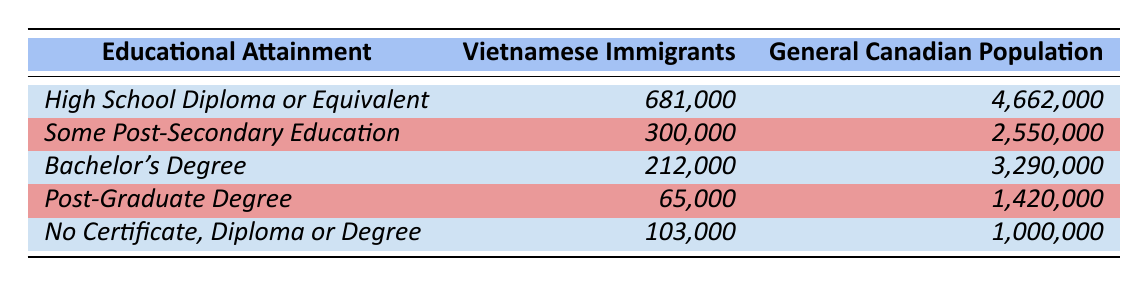What is the highest educational attainment level for Vietnamese immigrants? The table shows that the highest educational attainment level for Vietnamese immigrants is a "High School Diploma or Equivalent," which has the highest number at 681,000.
Answer: High School Diploma or Equivalent How many Vietnamese immigrants have a Bachelor's degree? According to the table, the number of Vietnamese immigrants with a Bachelor's degree is 212,000, as indicated in the corresponding row.
Answer: 212,000 What percentage of the general Canadian population has a Post-Graduate Degree? The total number of individuals in the general Canadian population is 4,662,000 + 2,550,000 + 3,290,000 + 1,420,000 + 1,000,000 = 12,922,000. The number of individuals with a Post-Graduate Degree is 1,420,000. The percentage is (1,420,000 / 12,922,000) * 100 ≈ 10.98%.
Answer: Approximately 10.98% Do more Vietnamese immigrants have "No Certificate, Diploma or Degree" than the General Canadian Population? The table indicates that 103,000 Vietnamese immigrants have "No Certificate, Diploma or Degree," while the general Canadian population has 1,000,000. Since 103,000 is less than 1,000,000, the answer is no.
Answer: No How do the numbers of "Some Post-Secondary Education" compare between the two groups? Vietnamese immigrants have 300,000 with "Some Post-Secondary Education," while the general Canadian population has 2,550,000. Comparing these numbers shows that Vietnamese immigrants have significantly fewer individuals in this category.
Answer: Vietnamese immigrants have fewer What is the total number of Vietnamese immigrants with "High School Diploma or Equivalent" and "Some Post-Secondary Education"? To find this total, we add the number of Vietnamese immigrants with "High School Diploma or Equivalent" (681,000) and those with "Some Post-Secondary Education" (300,000). The total is 681,000 + 300,000 = 981,000.
Answer: 981,000 Is it true that more than half of the general Canadian population has a high school diploma or equivalent? The table shows that 4,662,000 individuals in the general Canadian population have a high school diploma or equivalent. To determine if it's more than half, we compare this number to half of the total population (12,922,000). Half of that value is 6,461,000, which is greater, indicating that yes, more than half do hold this qualification.
Answer: Yes How many more Vietnamese immigrants have a Bachelor's degree compared to those with a Post-Graduate Degree? The difference is calculated by subtracting the number of Vietnamese immigrants with a Post-Graduate Degree (65,000) from those with a Bachelor's degree (212,000). The result is 212,000 - 65,000 = 147,000 more individuals with a Bachelor's degree.
Answer: 147,000 more 